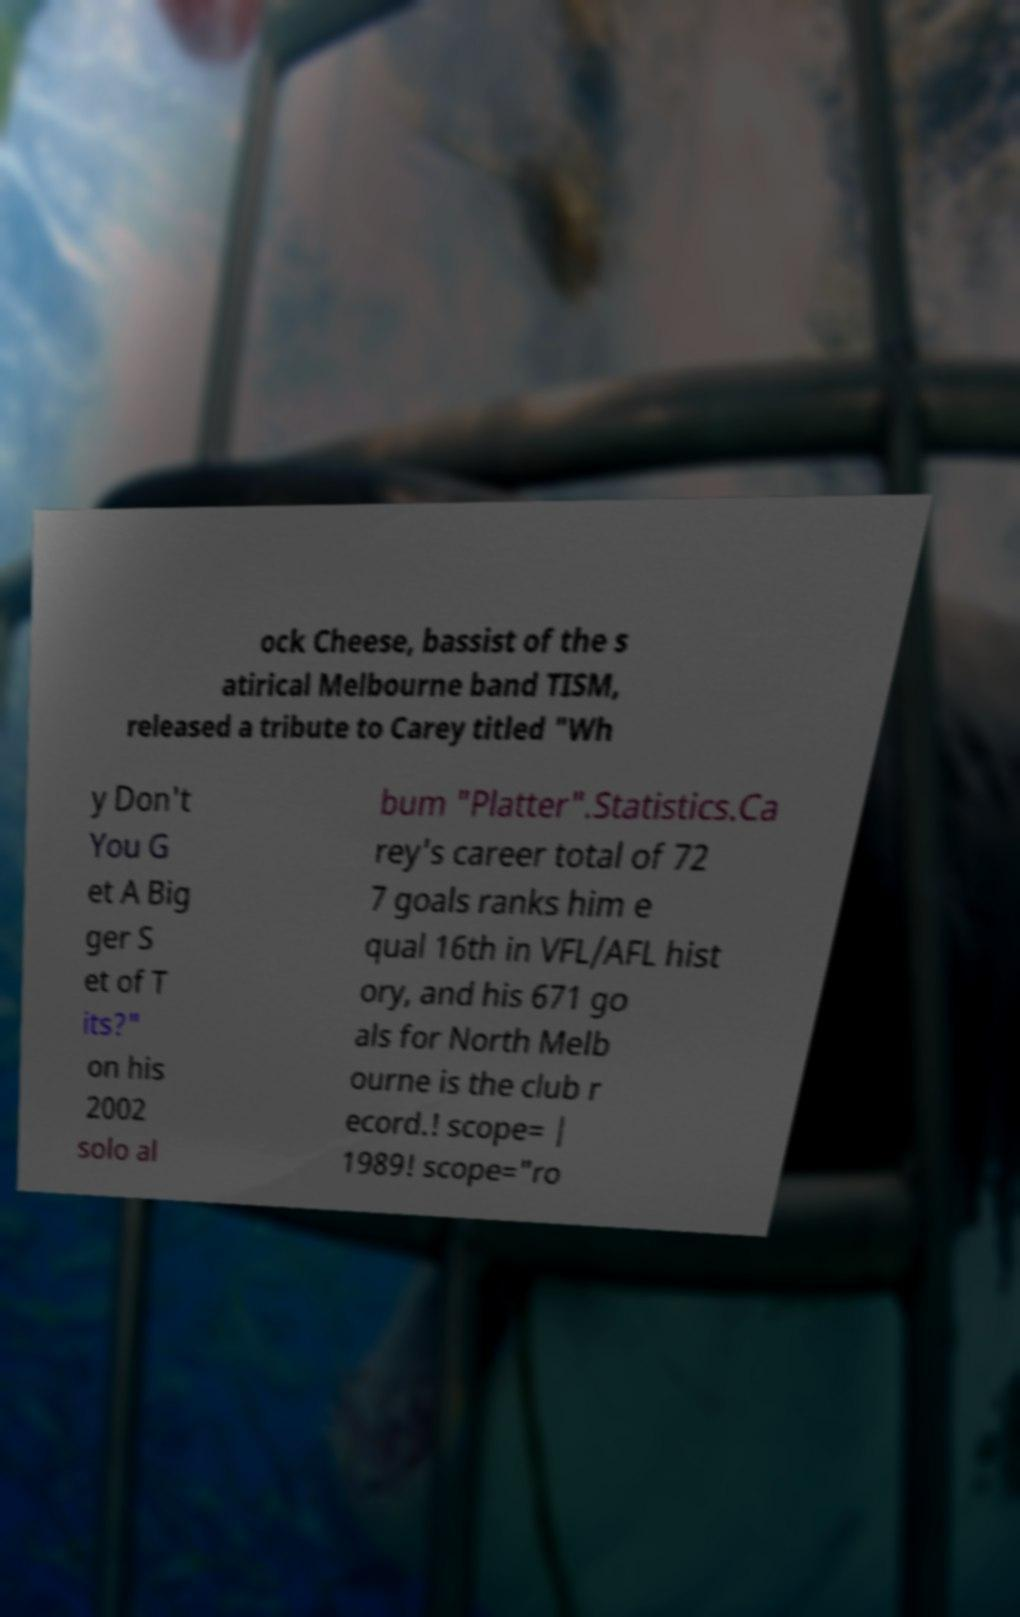Please read and relay the text visible in this image. What does it say? ock Cheese, bassist of the s atirical Melbourne band TISM, released a tribute to Carey titled "Wh y Don't You G et A Big ger S et of T its?" on his 2002 solo al bum "Platter".Statistics.Ca rey's career total of 72 7 goals ranks him e qual 16th in VFL/AFL hist ory, and his 671 go als for North Melb ourne is the club r ecord.! scope= | 1989! scope="ro 